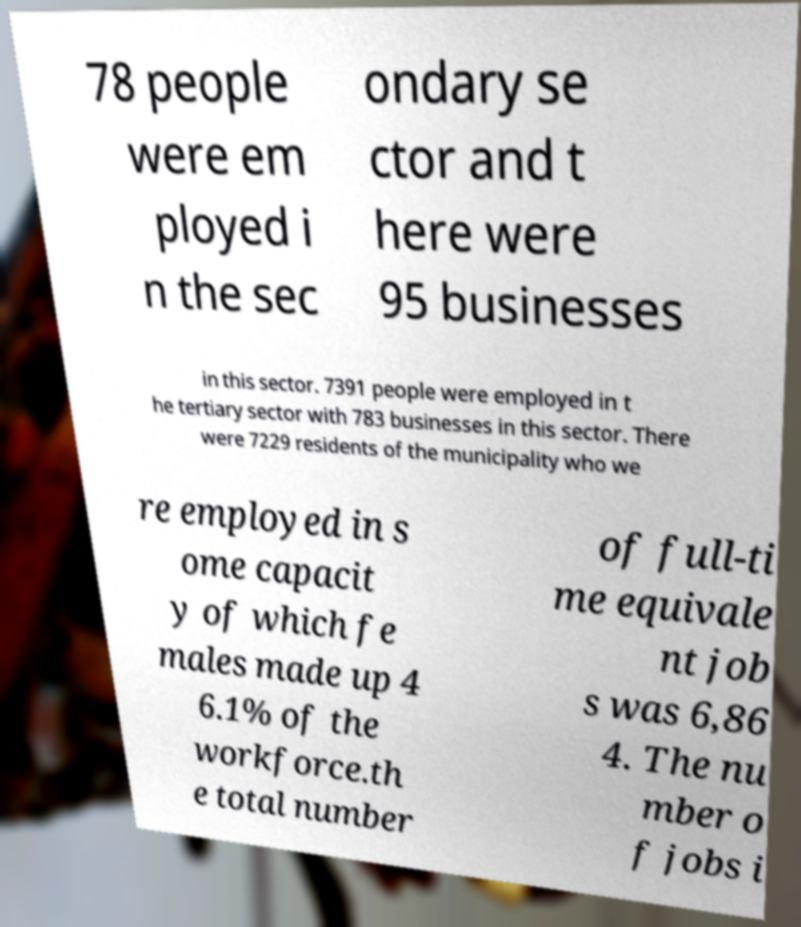Can you accurately transcribe the text from the provided image for me? 78 people were em ployed i n the sec ondary se ctor and t here were 95 businesses in this sector. 7391 people were employed in t he tertiary sector with 783 businesses in this sector. There were 7229 residents of the municipality who we re employed in s ome capacit y of which fe males made up 4 6.1% of the workforce.th e total number of full-ti me equivale nt job s was 6,86 4. The nu mber o f jobs i 